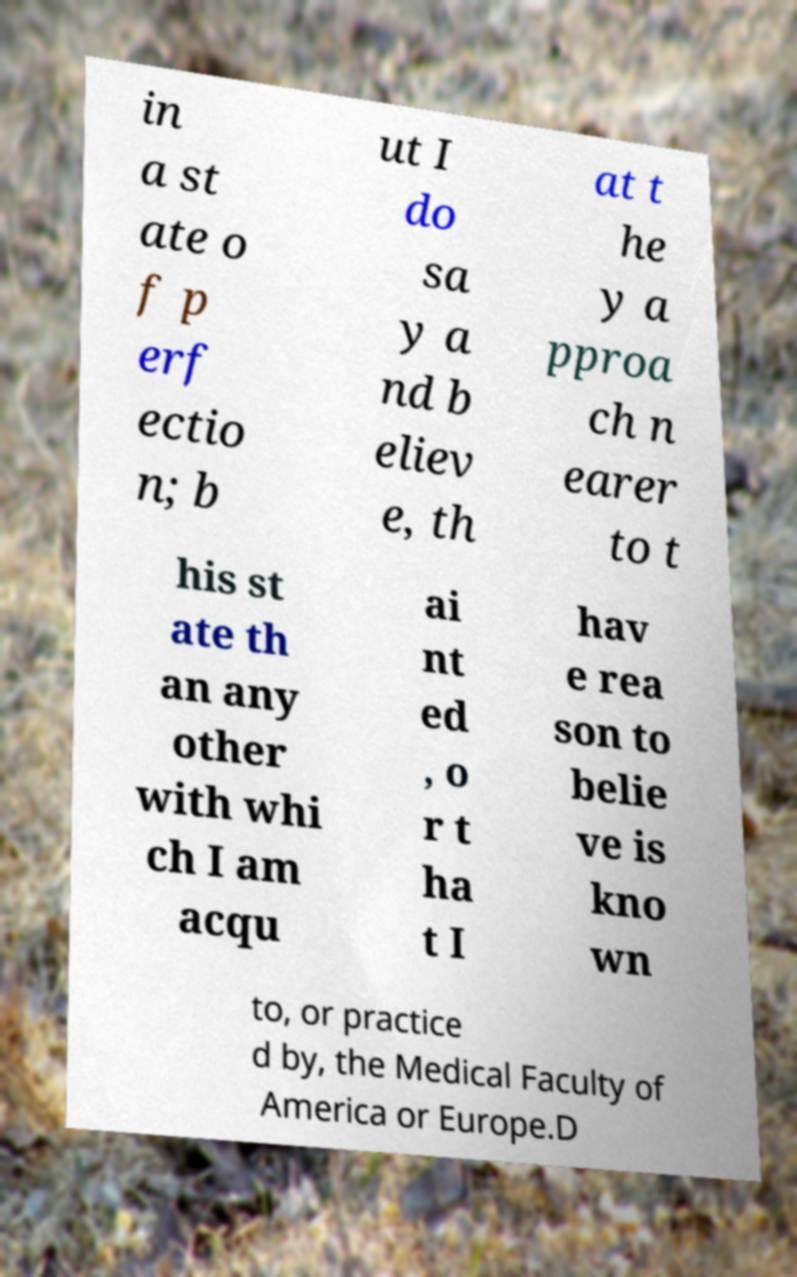For documentation purposes, I need the text within this image transcribed. Could you provide that? in a st ate o f p erf ectio n; b ut I do sa y a nd b eliev e, th at t he y a pproa ch n earer to t his st ate th an any other with whi ch I am acqu ai nt ed , o r t ha t I hav e rea son to belie ve is kno wn to, or practice d by, the Medical Faculty of America or Europe.D 